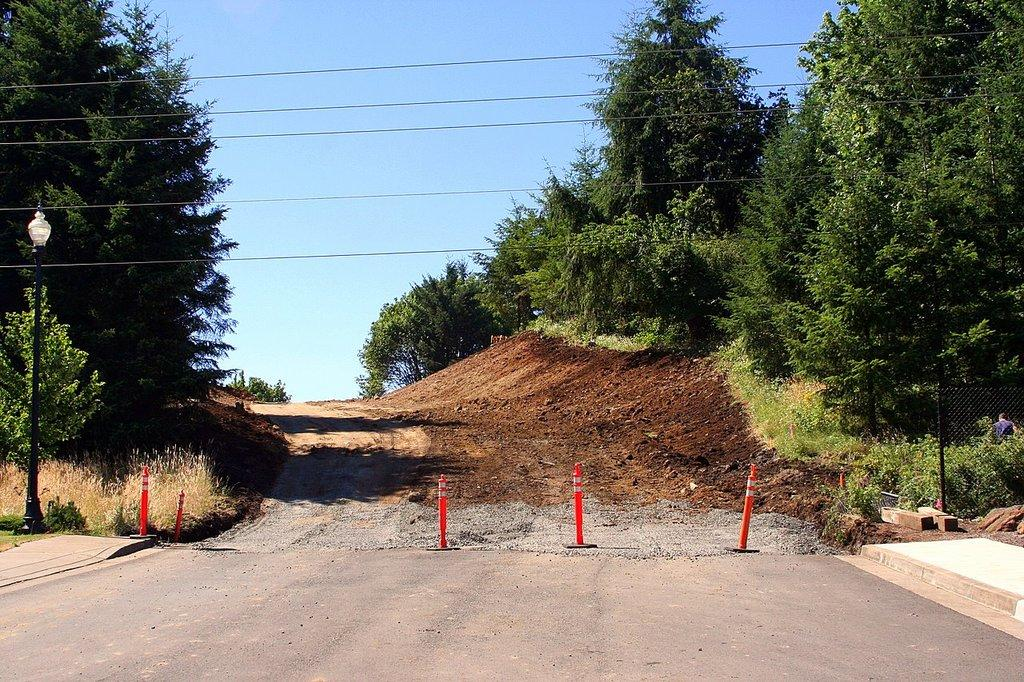What type of structures can be seen in the image? There are lane poles and a fence in the image. What can be found near the top of the image? There is a light in the image. What type of natural elements are present in the image? There are trees in the image. What is visible in the background of the image? The sky is visible in the background of the image. How many eyes can be seen on the fence in the image? There are no eyes present on the fence in the image. What type of experience can be gained from looking at the light in the image? The image itself does not provide any specific experience, as it is a static representation. 